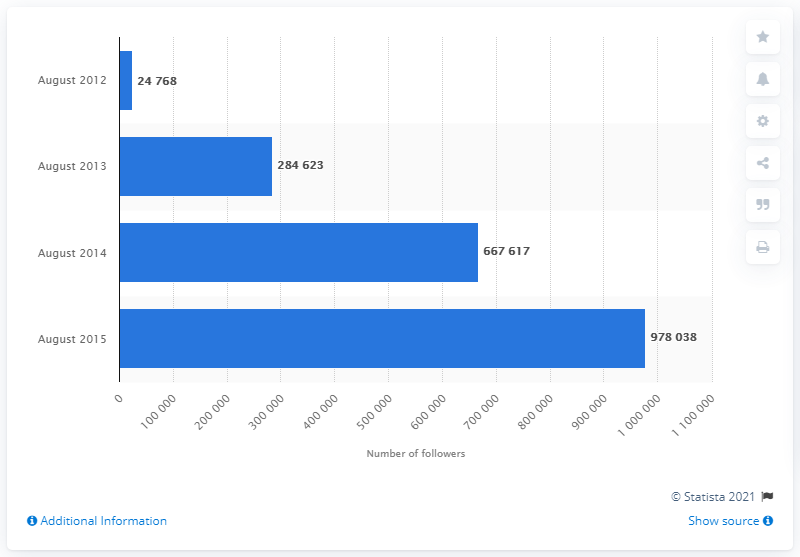Mention a couple of crucial points in this snapshot. In August 2012, IKEA had 24,768 followers on its Facebook page. 